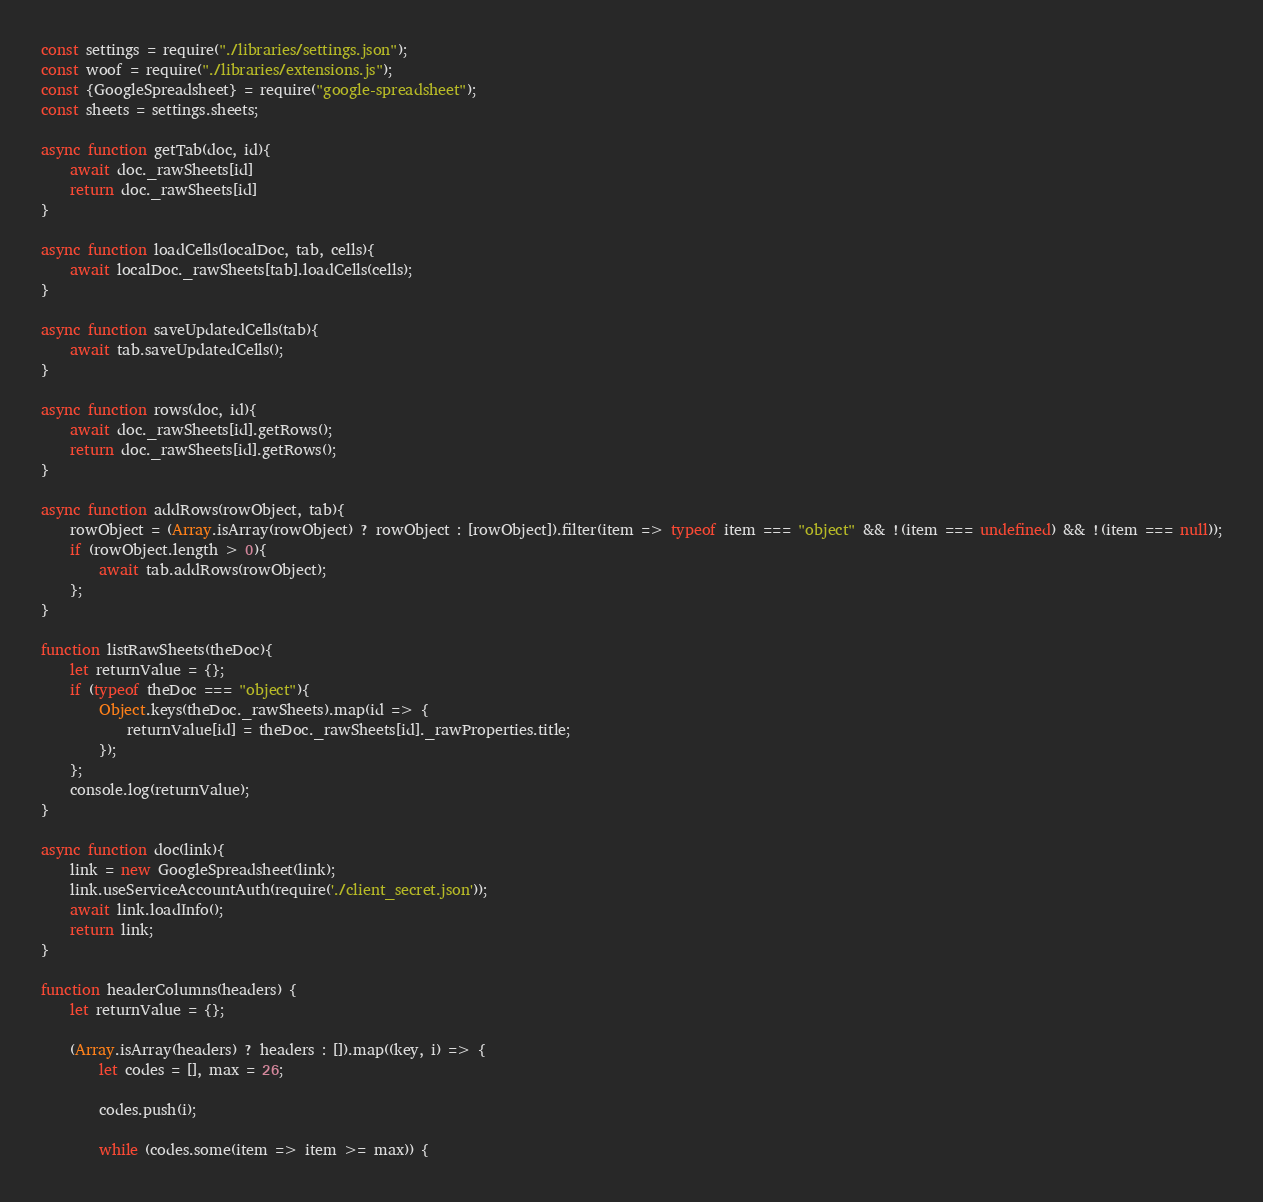Convert code to text. <code><loc_0><loc_0><loc_500><loc_500><_JavaScript_>const settings = require("./libraries/settings.json");
const woof = require("./libraries/extensions.js");
const {GoogleSpreadsheet} = require("google-spreadsheet");
const sheets = settings.sheets;

async function getTab(doc, id){
    await doc._rawSheets[id]
    return doc._rawSheets[id]
}

async function loadCells(localDoc, tab, cells){
    await localDoc._rawSheets[tab].loadCells(cells);
}

async function saveUpdatedCells(tab){
    await tab.saveUpdatedCells();
}

async function rows(doc, id){
    await doc._rawSheets[id].getRows();
    return doc._rawSheets[id].getRows();
}

async function addRows(rowObject, tab){
    rowObject = (Array.isArray(rowObject) ? rowObject : [rowObject]).filter(item => typeof item === "object" && !(item === undefined) && !(item === null));
    if (rowObject.length > 0){
        await tab.addRows(rowObject);
    };
}

function listRawSheets(theDoc){
    let returnValue = {};
    if (typeof theDoc === "object"){
        Object.keys(theDoc._rawSheets).map(id => {
            returnValue[id] = theDoc._rawSheets[id]._rawProperties.title;
        });
    };
    console.log(returnValue);
}

async function doc(link){
    link = new GoogleSpreadsheet(link);
    link.useServiceAccountAuth(require('./client_secret.json'));
    await link.loadInfo();
    return link;
}

function headerColumns(headers) {
    let returnValue = {};

    (Array.isArray(headers) ? headers : []).map((key, i) => {
        let codes = [], max = 26;

        codes.push(i);

        while (codes.some(item => item >= max)) {</code> 